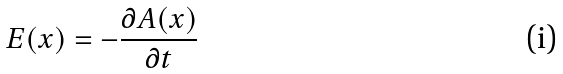Convert formula to latex. <formula><loc_0><loc_0><loc_500><loc_500>E ( x ) = - \frac { \partial A ( x ) } { \partial t }</formula> 